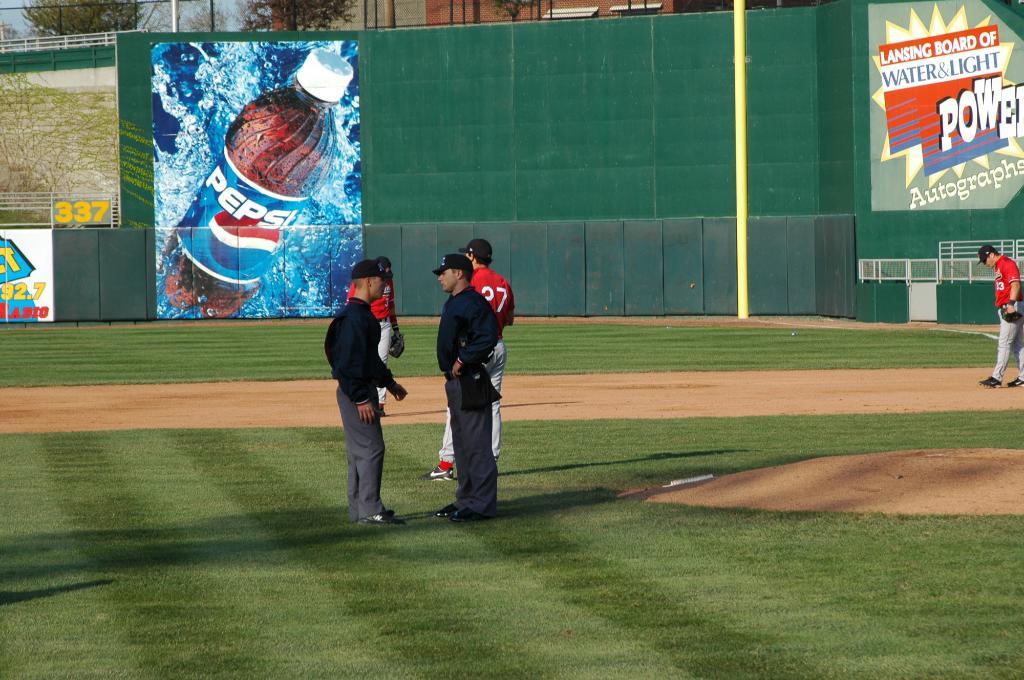What is the brand of the drink on the poster?
Provide a succinct answer. Pepsi. What number is written beside the pepsi brand?
Provide a short and direct response. 337. 